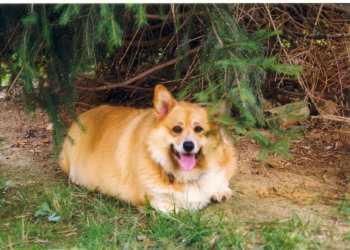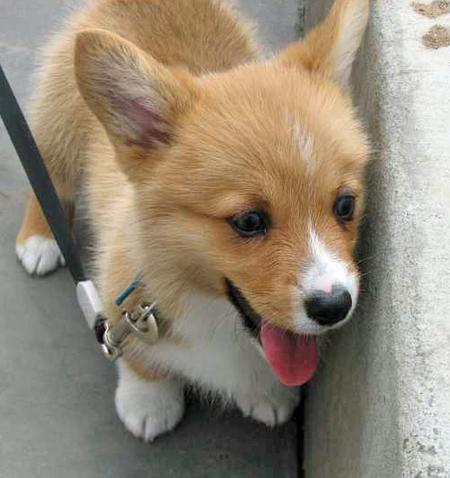The first image is the image on the left, the second image is the image on the right. Examine the images to the left and right. Is the description "A dog in the image on the left is lying down with its tongue hanging out." accurate? Answer yes or no. Yes. 